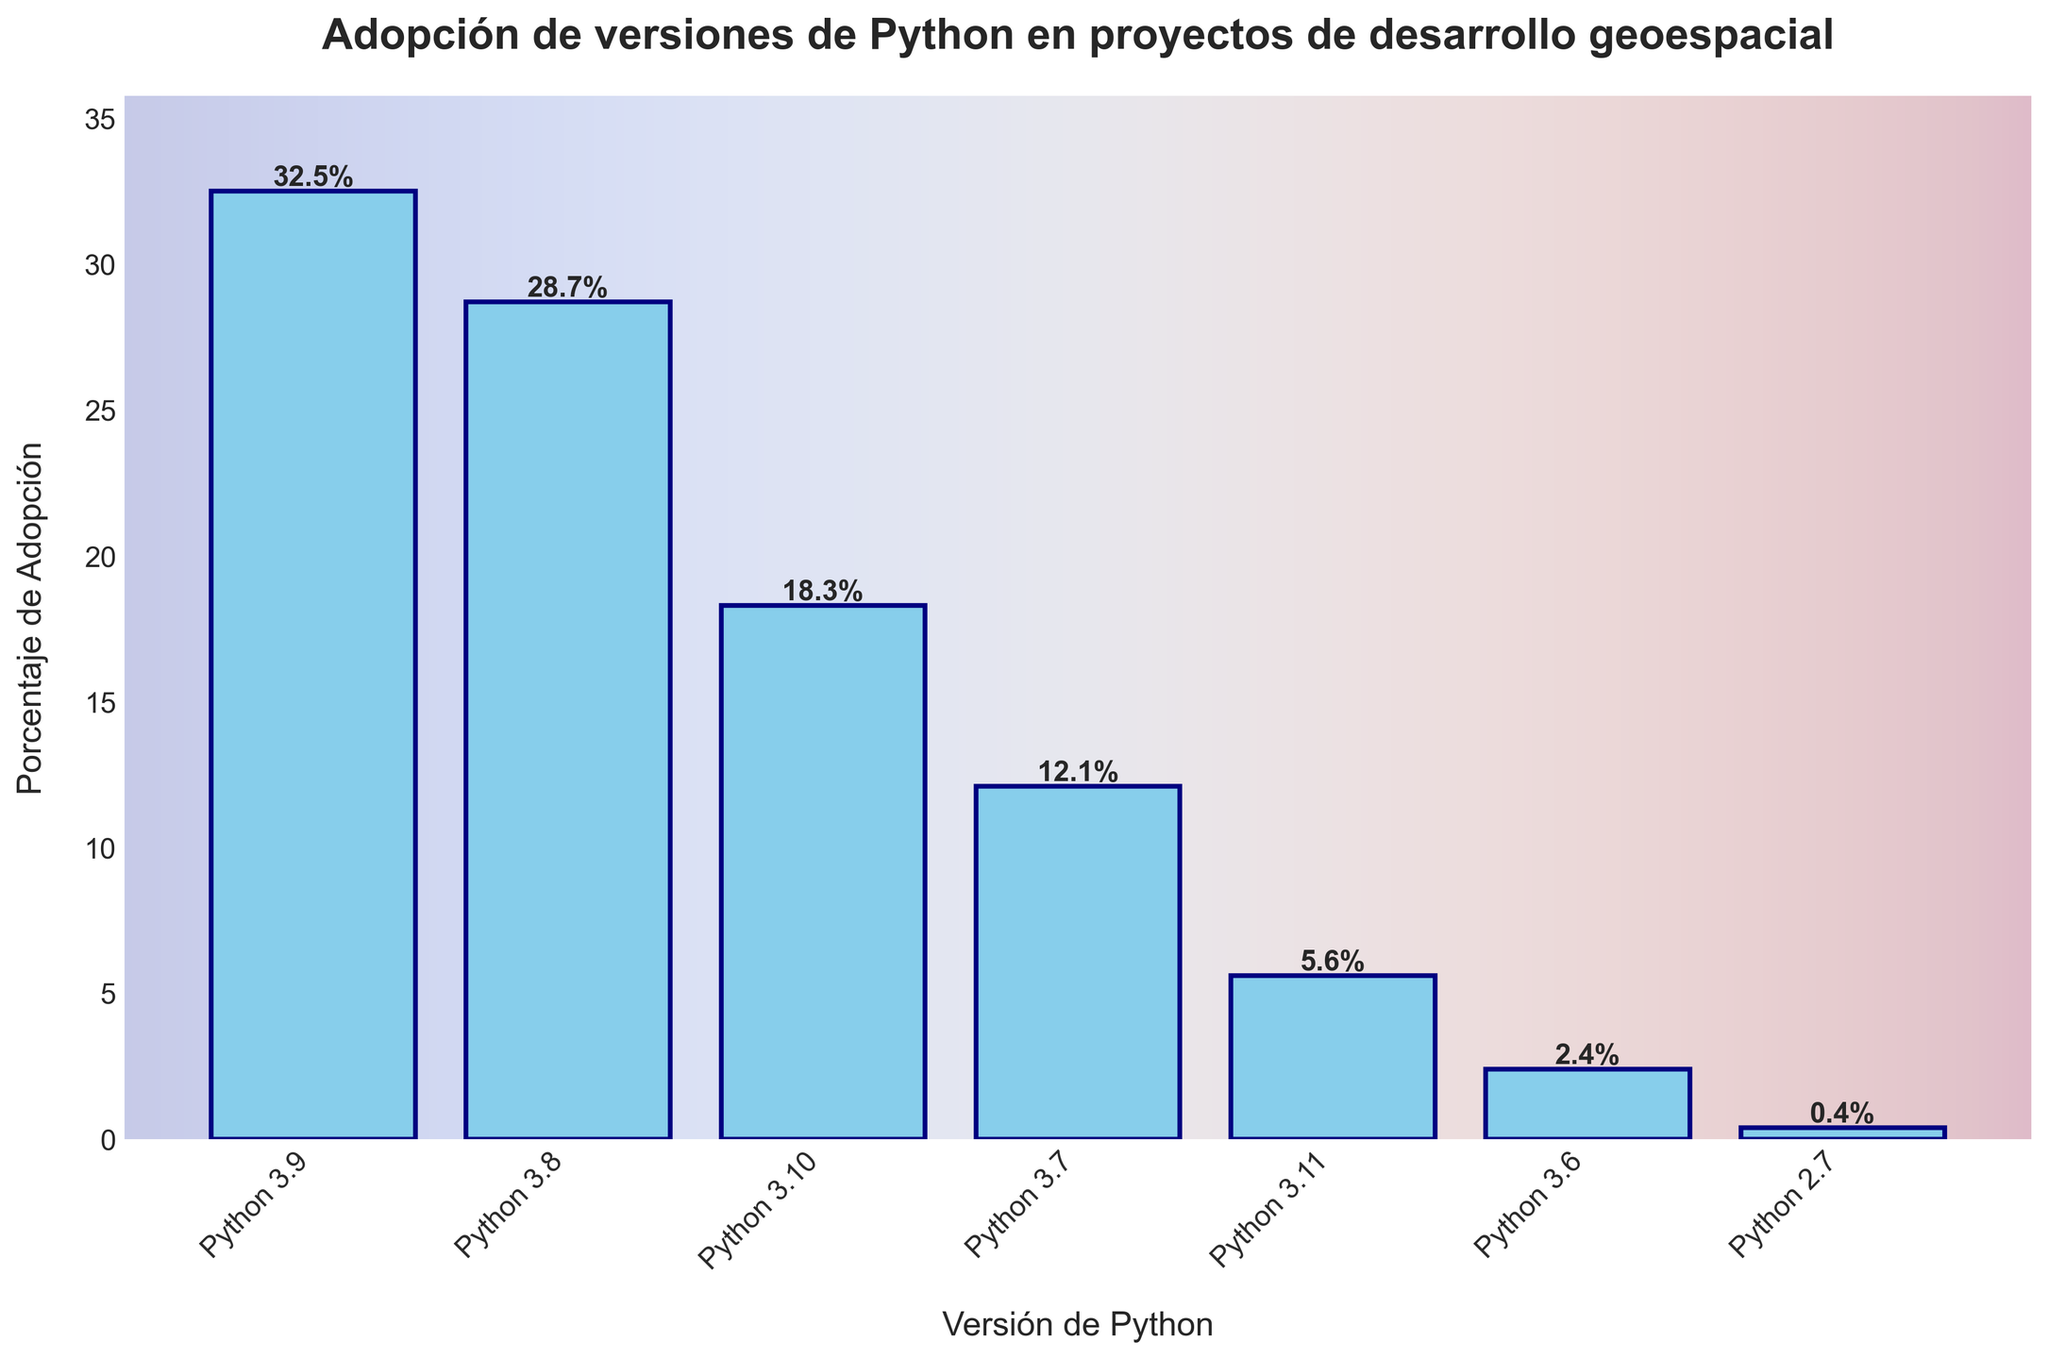¿Cuál versión de Python tiene la mayor adopción en proyectos de desarrollo geoespacial? Observando la altura de las barras, Python 3.9 es la más alta con un 32.5%.
Answer: Python 3.9 ¿Cuál es la diferencia en el porcentaje de adopción entre Python 3.9 y Python 3.8? El porcentaje de adopción de Python 3.9 es 32.5% y el de Python 3.8 es 28.7%. La diferencia es 32.5% - 28.7% = 3.8%.
Answer: 3.8% ¿Cómo se compara la adopción de Python 3.10 con la de Python 3.7? Python 3.10 tiene un 18.3% y Python 3.7 tiene un 12.1%. Comparando ambos, 18.3% es mayor que 12.1%.
Answer: Python 3.10 es mayor ¿Cuál es la suma total de los porcentajes de adopción para Python 3.11 y Python 3.6? Python 3.11 tiene un 5.6% y Python 3.6 tiene un 2.4%. La suma es 5.6% + 2.4% = 8%.
Answer: 8% ¿Qué porcentaje representa la adopción total de todas las versiones mostradas en el gráfico? Sumando todos los porcentajes: 32.5% + 28.7% + 18.3% + 12.1% + 5.6% + 2.4% + 0.4% = 100%.
Answer: 100% ¿Cómo se compara la adopción de Python 2.7 con respecto a todas las demás versiones? Python 2.7 tiene un 0.4%. Es notablemente menor que todas las demás versiones que están por encima del 2%.
Answer: Mucho menor ¿Cuál versión de Python tiene la menor adopción en proyectos de desarrollo geoespacial? Observando la barra más baja, Python 2.7 tiene el porcentaje de adopción más bajo con 0.4%.
Answer: Python 2.7 ¿Cuáles son las tres versiones de Python más adoptadas en proyectos de desarrollo geoespacial y sus porcentajes? Las tres barras más altas corresponden a Python 3.9 con 32.5%, Python 3.8 con 28.7%, y Python 3.10 con 18.3%.
Answer: Python 3.9: 32.5%, Python 3.8: 28.7%, Python 3.10: 18.3% ¿Qué tan grande es el incremento en el porcentaje de adopción de Python 3.9 comparado con Python 3.6? Python 3.9 tiene un 32.5% y Python 3.6 tiene un 2.4%. La diferencia es 32.5% - 2.4% = 30.1%.
Answer: 30.1% ¿Qué versión de Python cayó entre la adopción del 18.3% y 12.1%? Observando el gráfico, Python 3.10 tiene 18.3% y Python 3.7 tiene 12.1%, así que la versión que cae entre estos dos valores es Python 3.10.
Answer: Python 3.10 